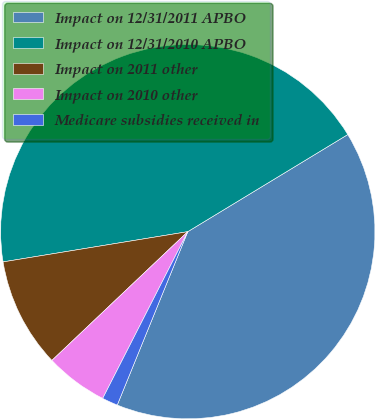Convert chart to OTSL. <chart><loc_0><loc_0><loc_500><loc_500><pie_chart><fcel>Impact on 12/31/2011 APBO<fcel>Impact on 12/31/2010 APBO<fcel>Impact on 2011 other<fcel>Impact on 2010 other<fcel>Medicare subsidies received in<nl><fcel>39.83%<fcel>43.9%<fcel>9.49%<fcel>5.42%<fcel>1.36%<nl></chart> 